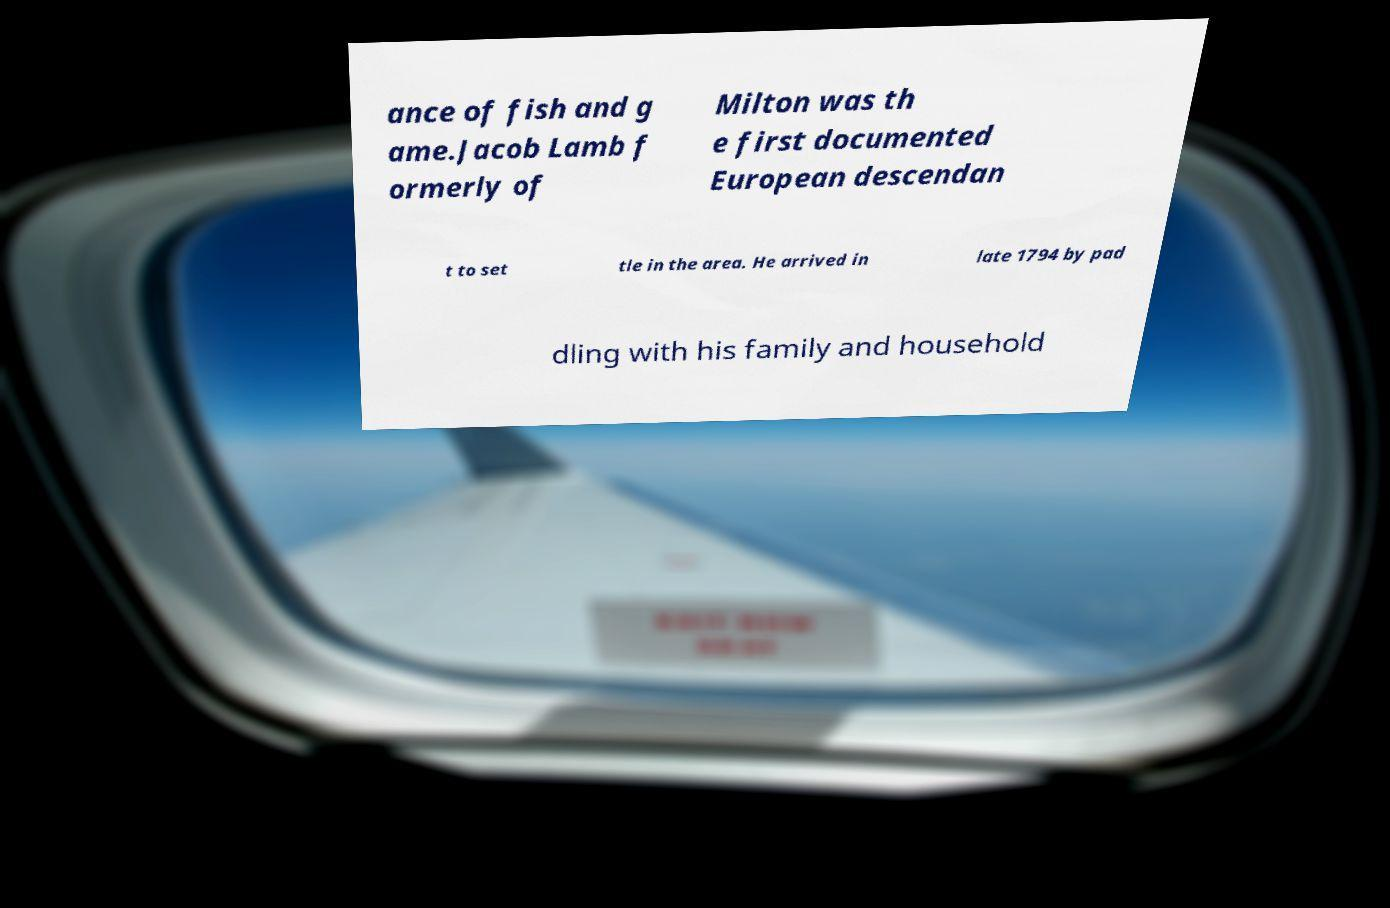I need the written content from this picture converted into text. Can you do that? ance of fish and g ame.Jacob Lamb f ormerly of Milton was th e first documented European descendan t to set tle in the area. He arrived in late 1794 by pad dling with his family and household 